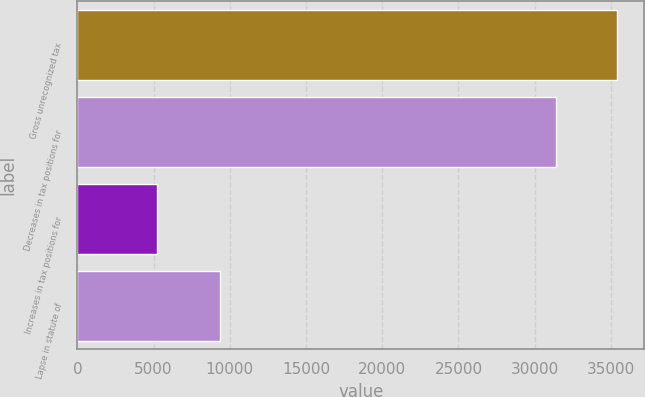<chart> <loc_0><loc_0><loc_500><loc_500><bar_chart><fcel>Gross unrecognized tax<fcel>Decreases in tax positions for<fcel>Increases in tax positions for<fcel>Lapse in statute of<nl><fcel>35421.2<fcel>31414<fcel>5195<fcel>9336<nl></chart> 